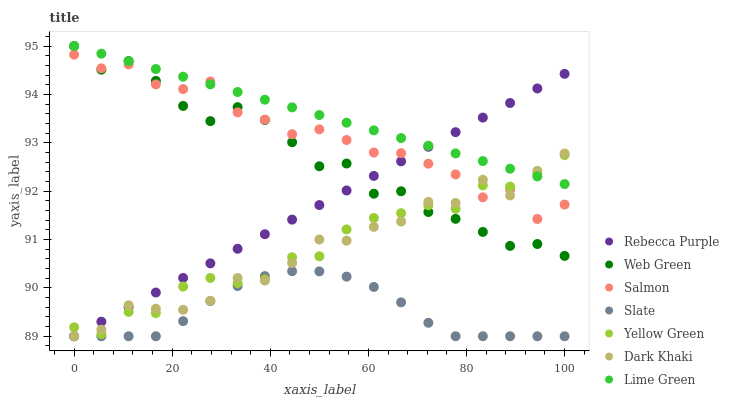Does Slate have the minimum area under the curve?
Answer yes or no. Yes. Does Lime Green have the maximum area under the curve?
Answer yes or no. Yes. Does Salmon have the minimum area under the curve?
Answer yes or no. No. Does Salmon have the maximum area under the curve?
Answer yes or no. No. Is Lime Green the smoothest?
Answer yes or no. Yes. Is Salmon the roughest?
Answer yes or no. Yes. Is Slate the smoothest?
Answer yes or no. No. Is Slate the roughest?
Answer yes or no. No. Does Slate have the lowest value?
Answer yes or no. Yes. Does Salmon have the lowest value?
Answer yes or no. No. Does Lime Green have the highest value?
Answer yes or no. Yes. Does Salmon have the highest value?
Answer yes or no. No. Is Slate less than Lime Green?
Answer yes or no. Yes. Is Lime Green greater than Slate?
Answer yes or no. Yes. Does Yellow Green intersect Rebecca Purple?
Answer yes or no. Yes. Is Yellow Green less than Rebecca Purple?
Answer yes or no. No. Is Yellow Green greater than Rebecca Purple?
Answer yes or no. No. Does Slate intersect Lime Green?
Answer yes or no. No. 